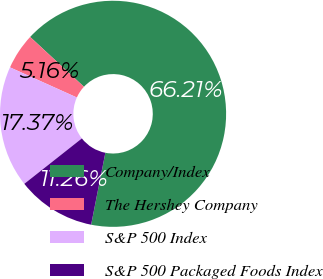Convert chart. <chart><loc_0><loc_0><loc_500><loc_500><pie_chart><fcel>Company/Index<fcel>The Hershey Company<fcel>S&P 500 Index<fcel>S&P 500 Packaged Foods Index<nl><fcel>66.21%<fcel>5.16%<fcel>17.37%<fcel>11.26%<nl></chart> 